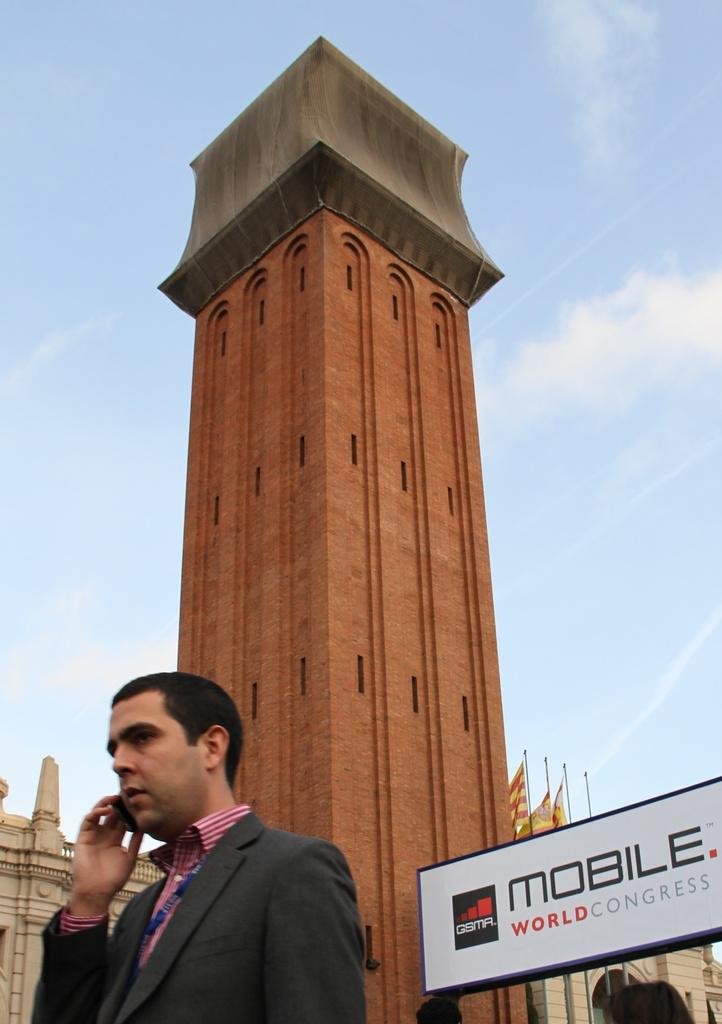What is the main structure in the image? There is a tower in the image. Who or what else can be seen in the image? There is a man in the image. What is on the right side of the image? There is a board on the right side of the image. What can be seen in the background of the image? There is a building in the background of the image. What else is visible in the image? There are flags and the sky visible in the image. What type of veil is draped over the tower in the image? There is no veil present in the image; the tower is not covered by any fabric or material. 